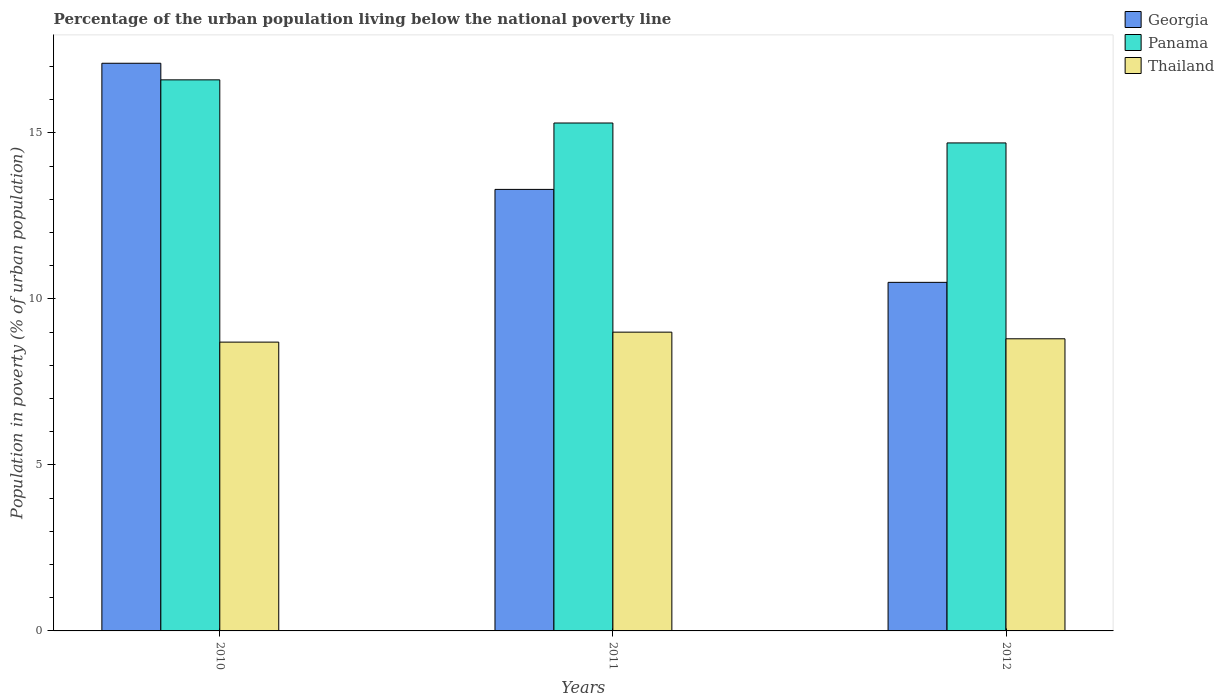How many different coloured bars are there?
Offer a terse response. 3. How many bars are there on the 1st tick from the left?
Keep it short and to the point. 3. How many bars are there on the 1st tick from the right?
Keep it short and to the point. 3. What is the label of the 1st group of bars from the left?
Provide a succinct answer. 2010. In how many cases, is the number of bars for a given year not equal to the number of legend labels?
Give a very brief answer. 0. Across all years, what is the maximum percentage of the urban population living below the national poverty line in Panama?
Make the answer very short. 16.6. What is the total percentage of the urban population living below the national poverty line in Thailand in the graph?
Ensure brevity in your answer.  26.5. What is the difference between the percentage of the urban population living below the national poverty line in Panama in 2011 and that in 2012?
Your answer should be very brief. 0.6. What is the difference between the percentage of the urban population living below the national poverty line in Thailand in 2011 and the percentage of the urban population living below the national poverty line in Panama in 2010?
Keep it short and to the point. -7.6. What is the average percentage of the urban population living below the national poverty line in Panama per year?
Give a very brief answer. 15.53. In the year 2012, what is the difference between the percentage of the urban population living below the national poverty line in Thailand and percentage of the urban population living below the national poverty line in Georgia?
Offer a very short reply. -1.7. In how many years, is the percentage of the urban population living below the national poverty line in Georgia greater than 6 %?
Provide a short and direct response. 3. What is the ratio of the percentage of the urban population living below the national poverty line in Thailand in 2010 to that in 2012?
Give a very brief answer. 0.99. Is the difference between the percentage of the urban population living below the national poverty line in Thailand in 2010 and 2012 greater than the difference between the percentage of the urban population living below the national poverty line in Georgia in 2010 and 2012?
Your answer should be compact. No. What is the difference between the highest and the second highest percentage of the urban population living below the national poverty line in Georgia?
Provide a short and direct response. 3.8. What is the difference between the highest and the lowest percentage of the urban population living below the national poverty line in Panama?
Provide a succinct answer. 1.9. In how many years, is the percentage of the urban population living below the national poverty line in Thailand greater than the average percentage of the urban population living below the national poverty line in Thailand taken over all years?
Provide a short and direct response. 1. Is the sum of the percentage of the urban population living below the national poverty line in Thailand in 2010 and 2012 greater than the maximum percentage of the urban population living below the national poverty line in Georgia across all years?
Your answer should be very brief. Yes. What does the 2nd bar from the left in 2011 represents?
Your answer should be very brief. Panama. What does the 3rd bar from the right in 2011 represents?
Ensure brevity in your answer.  Georgia. Are all the bars in the graph horizontal?
Give a very brief answer. No. What is the difference between two consecutive major ticks on the Y-axis?
Ensure brevity in your answer.  5. Are the values on the major ticks of Y-axis written in scientific E-notation?
Your answer should be very brief. No. Does the graph contain any zero values?
Offer a terse response. No. Does the graph contain grids?
Provide a succinct answer. No. Where does the legend appear in the graph?
Give a very brief answer. Top right. How many legend labels are there?
Your answer should be compact. 3. What is the title of the graph?
Provide a succinct answer. Percentage of the urban population living below the national poverty line. Does "Burkina Faso" appear as one of the legend labels in the graph?
Give a very brief answer. No. What is the label or title of the X-axis?
Provide a succinct answer. Years. What is the label or title of the Y-axis?
Your answer should be compact. Population in poverty (% of urban population). What is the Population in poverty (% of urban population) of Georgia in 2010?
Ensure brevity in your answer.  17.1. What is the Population in poverty (% of urban population) in Panama in 2012?
Your answer should be compact. 14.7. Across all years, what is the maximum Population in poverty (% of urban population) in Georgia?
Keep it short and to the point. 17.1. What is the total Population in poverty (% of urban population) in Georgia in the graph?
Give a very brief answer. 40.9. What is the total Population in poverty (% of urban population) in Panama in the graph?
Give a very brief answer. 46.6. What is the difference between the Population in poverty (% of urban population) of Georgia in 2010 and that in 2011?
Ensure brevity in your answer.  3.8. What is the difference between the Population in poverty (% of urban population) of Georgia in 2010 and that in 2012?
Your answer should be compact. 6.6. What is the difference between the Population in poverty (% of urban population) in Thailand in 2010 and that in 2012?
Provide a succinct answer. -0.1. What is the difference between the Population in poverty (% of urban population) in Panama in 2011 and that in 2012?
Ensure brevity in your answer.  0.6. What is the difference between the Population in poverty (% of urban population) of Thailand in 2011 and that in 2012?
Give a very brief answer. 0.2. What is the difference between the Population in poverty (% of urban population) of Georgia in 2010 and the Population in poverty (% of urban population) of Thailand in 2011?
Make the answer very short. 8.1. What is the difference between the Population in poverty (% of urban population) of Georgia in 2010 and the Population in poverty (% of urban population) of Panama in 2012?
Your response must be concise. 2.4. What is the difference between the Population in poverty (% of urban population) in Georgia in 2010 and the Population in poverty (% of urban population) in Thailand in 2012?
Offer a very short reply. 8.3. What is the difference between the Population in poverty (% of urban population) of Panama in 2010 and the Population in poverty (% of urban population) of Thailand in 2012?
Give a very brief answer. 7.8. What is the difference between the Population in poverty (% of urban population) of Georgia in 2011 and the Population in poverty (% of urban population) of Panama in 2012?
Give a very brief answer. -1.4. What is the difference between the Population in poverty (% of urban population) in Georgia in 2011 and the Population in poverty (% of urban population) in Thailand in 2012?
Give a very brief answer. 4.5. What is the average Population in poverty (% of urban population) of Georgia per year?
Provide a succinct answer. 13.63. What is the average Population in poverty (% of urban population) of Panama per year?
Your answer should be compact. 15.53. What is the average Population in poverty (% of urban population) of Thailand per year?
Provide a short and direct response. 8.83. In the year 2010, what is the difference between the Population in poverty (% of urban population) of Georgia and Population in poverty (% of urban population) of Panama?
Your response must be concise. 0.5. In the year 2010, what is the difference between the Population in poverty (% of urban population) in Georgia and Population in poverty (% of urban population) in Thailand?
Provide a succinct answer. 8.4. In the year 2011, what is the difference between the Population in poverty (% of urban population) in Georgia and Population in poverty (% of urban population) in Panama?
Keep it short and to the point. -2. In the year 2011, what is the difference between the Population in poverty (% of urban population) of Panama and Population in poverty (% of urban population) of Thailand?
Make the answer very short. 6.3. In the year 2012, what is the difference between the Population in poverty (% of urban population) in Panama and Population in poverty (% of urban population) in Thailand?
Offer a terse response. 5.9. What is the ratio of the Population in poverty (% of urban population) of Georgia in 2010 to that in 2011?
Keep it short and to the point. 1.29. What is the ratio of the Population in poverty (% of urban population) of Panama in 2010 to that in 2011?
Offer a very short reply. 1.08. What is the ratio of the Population in poverty (% of urban population) in Thailand in 2010 to that in 2011?
Provide a short and direct response. 0.97. What is the ratio of the Population in poverty (% of urban population) in Georgia in 2010 to that in 2012?
Provide a short and direct response. 1.63. What is the ratio of the Population in poverty (% of urban population) of Panama in 2010 to that in 2012?
Ensure brevity in your answer.  1.13. What is the ratio of the Population in poverty (% of urban population) of Thailand in 2010 to that in 2012?
Keep it short and to the point. 0.99. What is the ratio of the Population in poverty (% of urban population) of Georgia in 2011 to that in 2012?
Offer a terse response. 1.27. What is the ratio of the Population in poverty (% of urban population) of Panama in 2011 to that in 2012?
Ensure brevity in your answer.  1.04. What is the ratio of the Population in poverty (% of urban population) of Thailand in 2011 to that in 2012?
Offer a very short reply. 1.02. What is the difference between the highest and the second highest Population in poverty (% of urban population) in Georgia?
Make the answer very short. 3.8. 